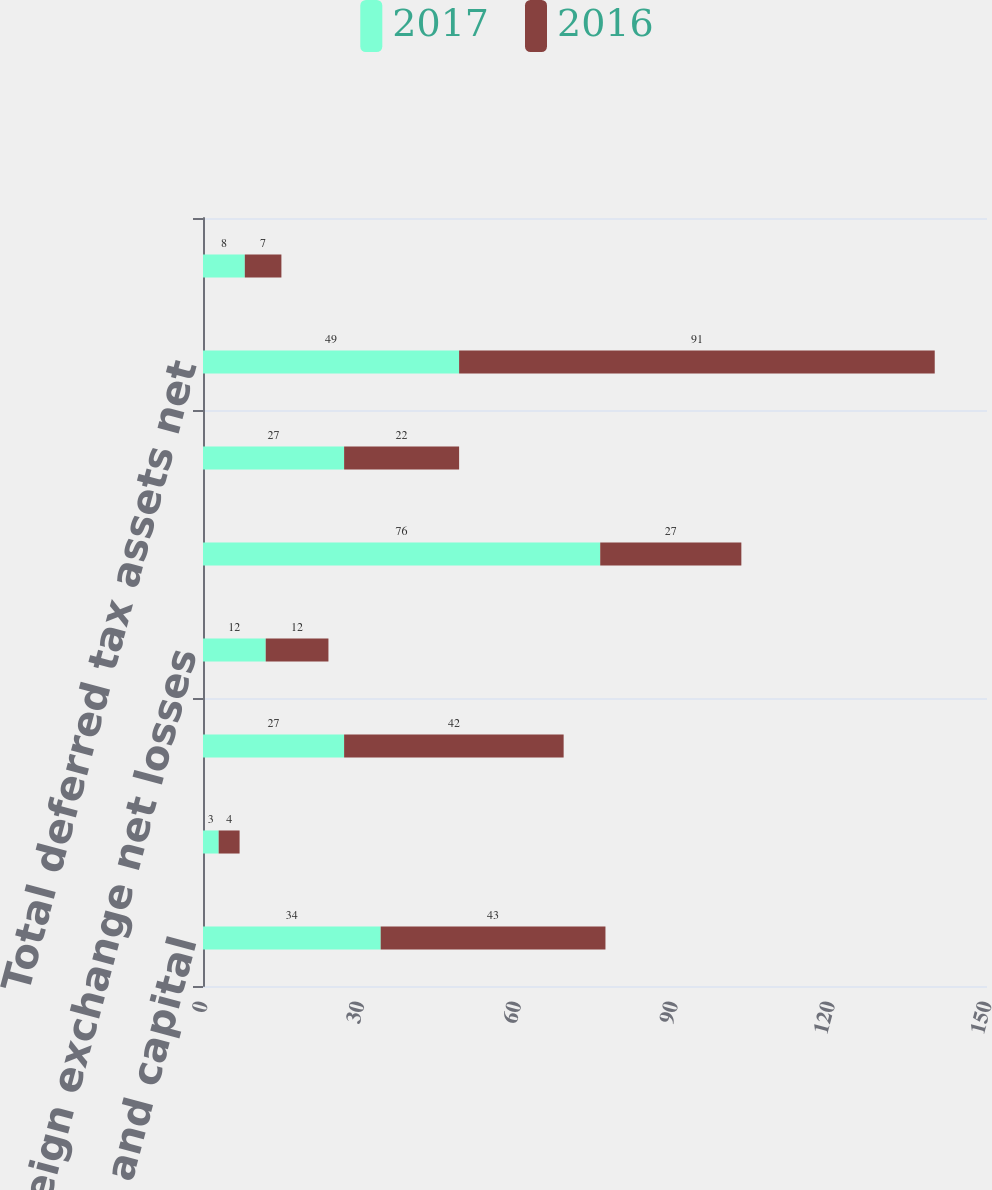Convert chart. <chart><loc_0><loc_0><loc_500><loc_500><stacked_bar_chart><ecel><fcel>Net operating loss and capital<fcel>Property and equipment<fcel>Deferred revenue and expenses<fcel>Foreign exchange net losses<fcel>Total gross deferred tax<fcel>Less Valuation allowance<fcel>Total deferred tax assets net<fcel>Investments in domestic and<nl><fcel>2017<fcel>34<fcel>3<fcel>27<fcel>12<fcel>76<fcel>27<fcel>49<fcel>8<nl><fcel>2016<fcel>43<fcel>4<fcel>42<fcel>12<fcel>27<fcel>22<fcel>91<fcel>7<nl></chart> 